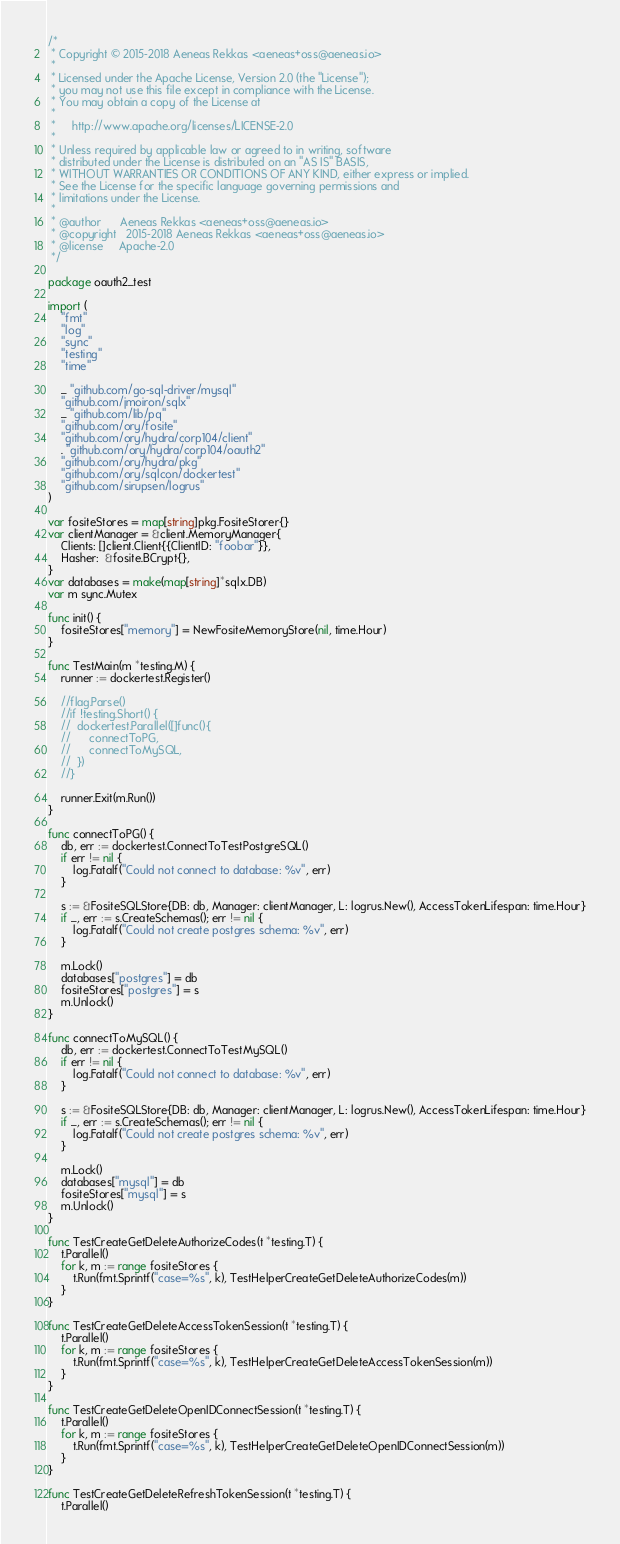Convert code to text. <code><loc_0><loc_0><loc_500><loc_500><_Go_>/*
 * Copyright © 2015-2018 Aeneas Rekkas <aeneas+oss@aeneas.io>
 *
 * Licensed under the Apache License, Version 2.0 (the "License");
 * you may not use this file except in compliance with the License.
 * You may obtain a copy of the License at
 *
 *     http://www.apache.org/licenses/LICENSE-2.0
 *
 * Unless required by applicable law or agreed to in writing, software
 * distributed under the License is distributed on an "AS IS" BASIS,
 * WITHOUT WARRANTIES OR CONDITIONS OF ANY KIND, either express or implied.
 * See the License for the specific language governing permissions and
 * limitations under the License.
 *
 * @author		Aeneas Rekkas <aeneas+oss@aeneas.io>
 * @copyright 	2015-2018 Aeneas Rekkas <aeneas+oss@aeneas.io>
 * @license 	Apache-2.0
 */

package oauth2_test

import (
	"fmt"
	"log"
	"sync"
	"testing"
	"time"

	_ "github.com/go-sql-driver/mysql"
	"github.com/jmoiron/sqlx"
	_ "github.com/lib/pq"
	"github.com/ory/fosite"
	"github.com/ory/hydra/corp104/client"
	. "github.com/ory/hydra/corp104/oauth2"
	"github.com/ory/hydra/pkg"
	"github.com/ory/sqlcon/dockertest"
	"github.com/sirupsen/logrus"
)

var fositeStores = map[string]pkg.FositeStorer{}
var clientManager = &client.MemoryManager{
	Clients: []client.Client{{ClientID: "foobar"}},
	Hasher:  &fosite.BCrypt{},
}
var databases = make(map[string]*sqlx.DB)
var m sync.Mutex

func init() {
	fositeStores["memory"] = NewFositeMemoryStore(nil, time.Hour)
}

func TestMain(m *testing.M) {
	runner := dockertest.Register()

	//flag.Parse()
	//if !testing.Short() {
	//	dockertest.Parallel([]func(){
	//		connectToPG,
	//		connectToMySQL,
	//	})
	//}

	runner.Exit(m.Run())
}

func connectToPG() {
	db, err := dockertest.ConnectToTestPostgreSQL()
	if err != nil {
		log.Fatalf("Could not connect to database: %v", err)
	}

	s := &FositeSQLStore{DB: db, Manager: clientManager, L: logrus.New(), AccessTokenLifespan: time.Hour}
	if _, err := s.CreateSchemas(); err != nil {
		log.Fatalf("Could not create postgres schema: %v", err)
	}

	m.Lock()
	databases["postgres"] = db
	fositeStores["postgres"] = s
	m.Unlock()
}

func connectToMySQL() {
	db, err := dockertest.ConnectToTestMySQL()
	if err != nil {
		log.Fatalf("Could not connect to database: %v", err)
	}

	s := &FositeSQLStore{DB: db, Manager: clientManager, L: logrus.New(), AccessTokenLifespan: time.Hour}
	if _, err := s.CreateSchemas(); err != nil {
		log.Fatalf("Could not create postgres schema: %v", err)
	}

	m.Lock()
	databases["mysql"] = db
	fositeStores["mysql"] = s
	m.Unlock()
}

func TestCreateGetDeleteAuthorizeCodes(t *testing.T) {
	t.Parallel()
	for k, m := range fositeStores {
		t.Run(fmt.Sprintf("case=%s", k), TestHelperCreateGetDeleteAuthorizeCodes(m))
	}
}

func TestCreateGetDeleteAccessTokenSession(t *testing.T) {
	t.Parallel()
	for k, m := range fositeStores {
		t.Run(fmt.Sprintf("case=%s", k), TestHelperCreateGetDeleteAccessTokenSession(m))
	}
}

func TestCreateGetDeleteOpenIDConnectSession(t *testing.T) {
	t.Parallel()
	for k, m := range fositeStores {
		t.Run(fmt.Sprintf("case=%s", k), TestHelperCreateGetDeleteOpenIDConnectSession(m))
	}
}

func TestCreateGetDeleteRefreshTokenSession(t *testing.T) {
	t.Parallel()</code> 